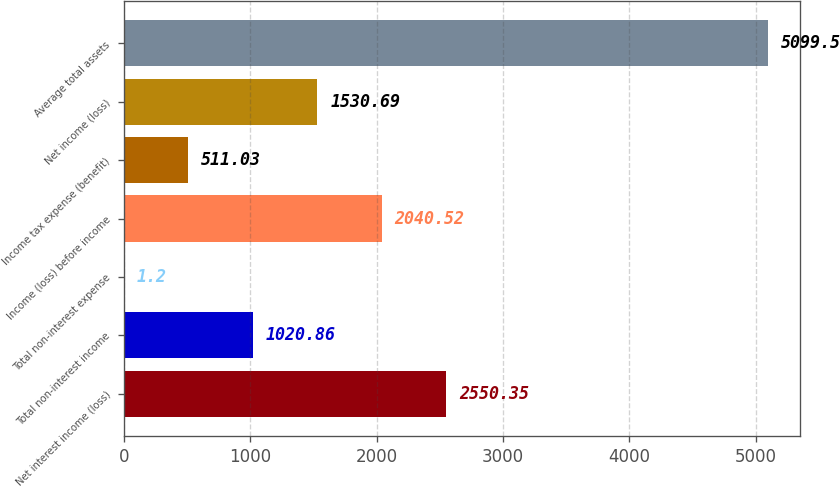Convert chart to OTSL. <chart><loc_0><loc_0><loc_500><loc_500><bar_chart><fcel>Net interest income (loss)<fcel>Total non-interest income<fcel>Total non-interest expense<fcel>Income (loss) before income<fcel>Income tax expense (benefit)<fcel>Net income (loss)<fcel>Average total assets<nl><fcel>2550.35<fcel>1020.86<fcel>1.2<fcel>2040.52<fcel>511.03<fcel>1530.69<fcel>5099.5<nl></chart> 